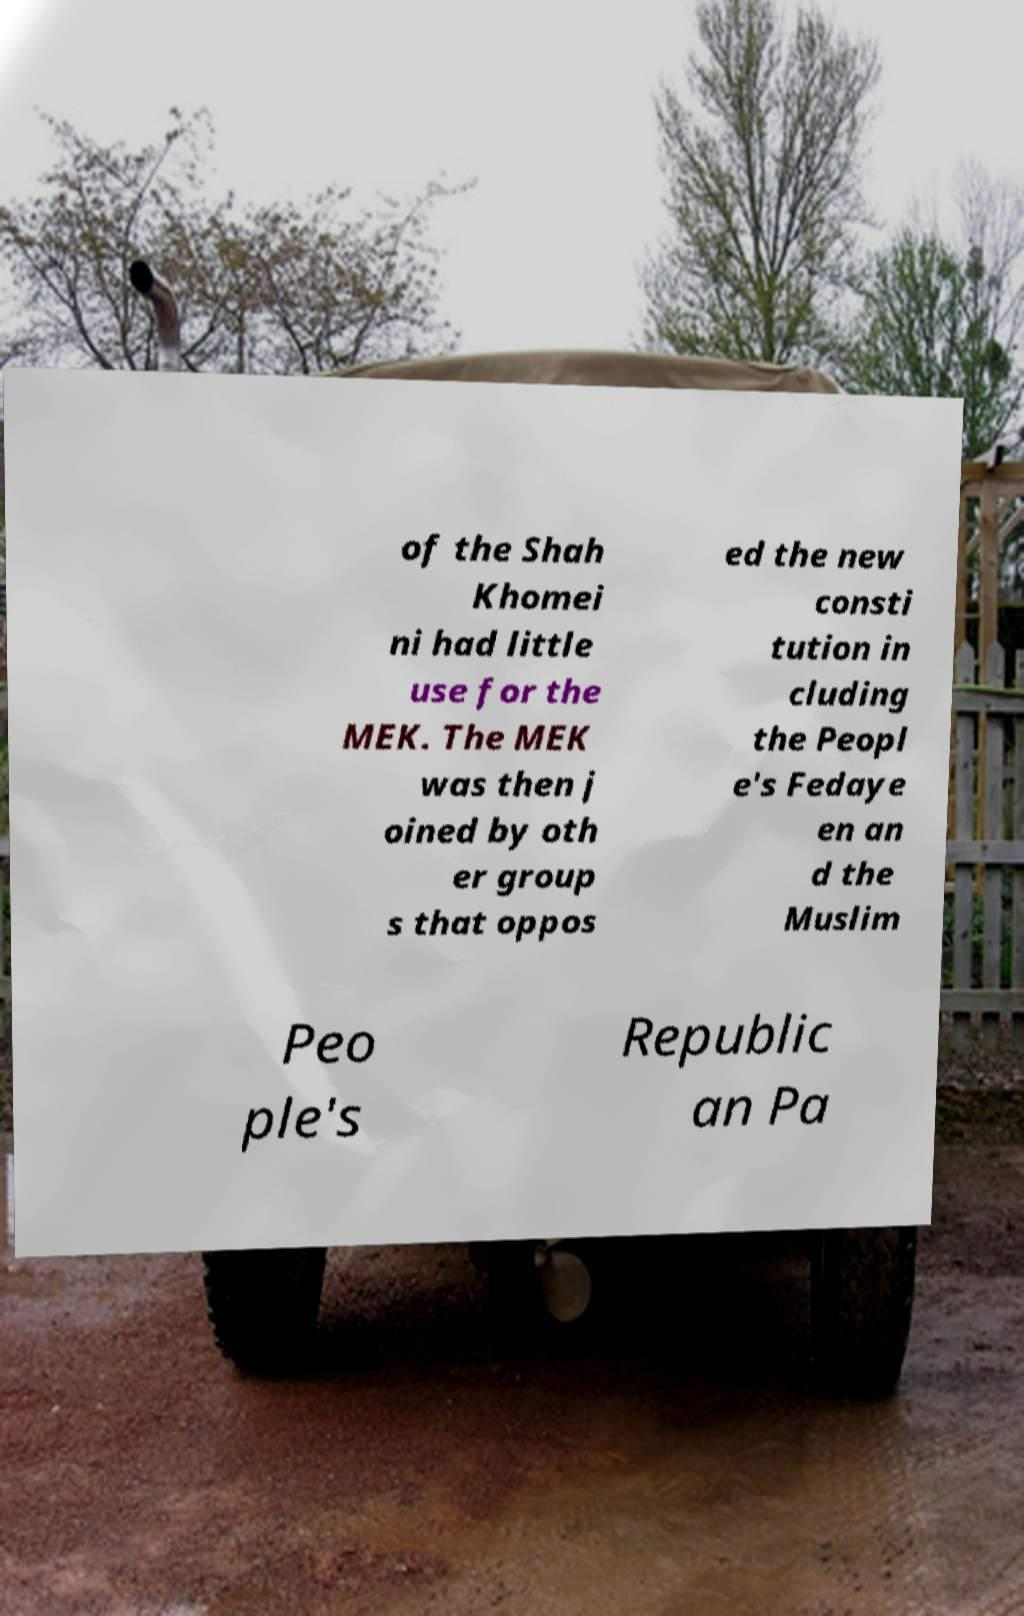Can you accurately transcribe the text from the provided image for me? of the Shah Khomei ni had little use for the MEK. The MEK was then j oined by oth er group s that oppos ed the new consti tution in cluding the Peopl e's Fedaye en an d the Muslim Peo ple's Republic an Pa 